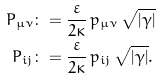<formula> <loc_0><loc_0><loc_500><loc_500>{ P } _ { \mu \nu } & \colon = \frac { \varepsilon } { 2 \kappa } \, { p } _ { \mu \nu } \, \sqrt { | \gamma | } \\ P _ { i j } & \colon = \frac { \varepsilon } { 2 \kappa } \, p _ { i j } \, \sqrt { | \gamma | } .</formula> 